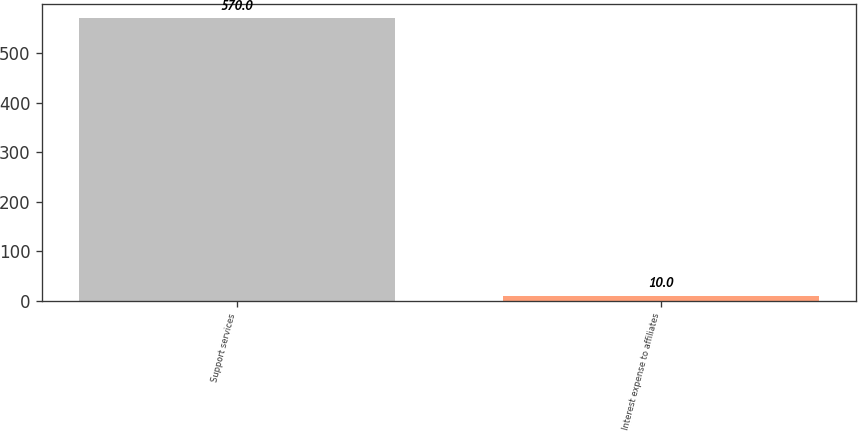Convert chart. <chart><loc_0><loc_0><loc_500><loc_500><bar_chart><fcel>Support services<fcel>Interest expense to affiliates<nl><fcel>570<fcel>10<nl></chart> 